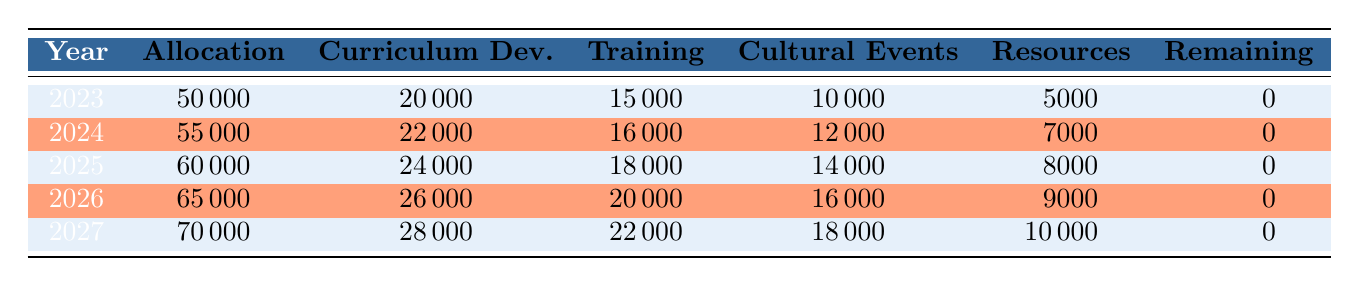What was the allocation for the year 2025? The table displays the allocation for each year, and for 2025, the allocation is listed directly under that year.
Answer: 60000 What was the highest allocation amount throughout the years? By comparing the allocation figures from each year, I see that the highest allocation listed is for 2027, which is 70000.
Answer: 70000 How much was spent on cultural events in 2024? The expenses for cultural events in 2024 are shown in that row, specifically under the cultural events column, indicating it was 12000.
Answer: 12000 If the expenses for training workshops grow by 10% each year starting from 2023, what would the expense be in 2025? The training workshop expenses in 2023 are 15000. By calculating 10% growth for two years: 15000 * 1.1 = 16500 (for 2024), and 16500 * 1.1 = 18150 for 2025. This indicates that the expected expense for training workshops in 2025 is 18150.
Answer: 18150 Was the remaining budget for any year greater than zero? The table shows a column for remaining budget and indicates that the remaining budget for each year is 0, meaning there was no excess budget any year.
Answer: No What is the total expense for curriculum development over all the years? To answer this, I will sum the curriculum development expenses for each year: 20000 + 22000 + 24000 + 26000 + 28000 = 120000. So, the total for curriculum development is 120000.
Answer: 120000 What was the average allocation from 2023 to 2027? There are five allocations: 50000, 55000, 60000, 65000, and 70000. The total allocation is 50000 + 55000 + 60000 + 65000 + 70000 = 300000. To find the average, I divide the total by the number of years (5): 300000 / 5 = 60000.
Answer: 60000 How much more was spent on resources in 2026 compared to 2023? From the table, I find the expense for resources in 2026 is 9000 and in 2023 it is 5000. The difference is calculated as 9000 - 5000 = 4000, indicating that 4000 more was spent on resources in 2026 than in 2023.
Answer: 4000 Did the total expenses increase each year? To determine this, I check if each total expense row exceeds the previous one. The expenses for each year are summarized as follows: 50000 (2023), 55000 (2024), 60000 (2025), 65000 (2026), 70000 (2027). Since each amount increases, I conclude that the total expenses did indeed increase each year.
Answer: Yes 